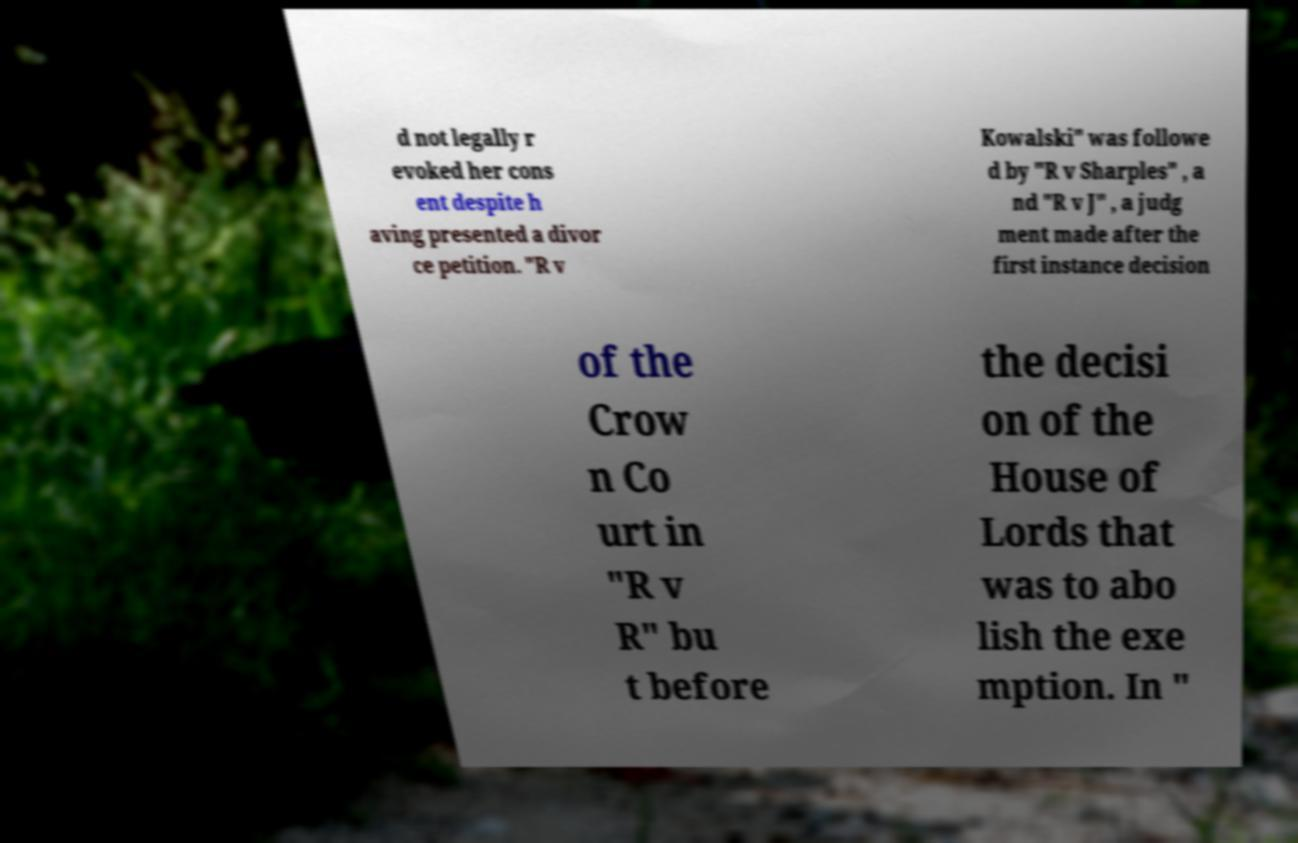I need the written content from this picture converted into text. Can you do that? d not legally r evoked her cons ent despite h aving presented a divor ce petition. "R v Kowalski" was followe d by "R v Sharples" , a nd "R v J" , a judg ment made after the first instance decision of the Crow n Co urt in "R v R" bu t before the decisi on of the House of Lords that was to abo lish the exe mption. In " 